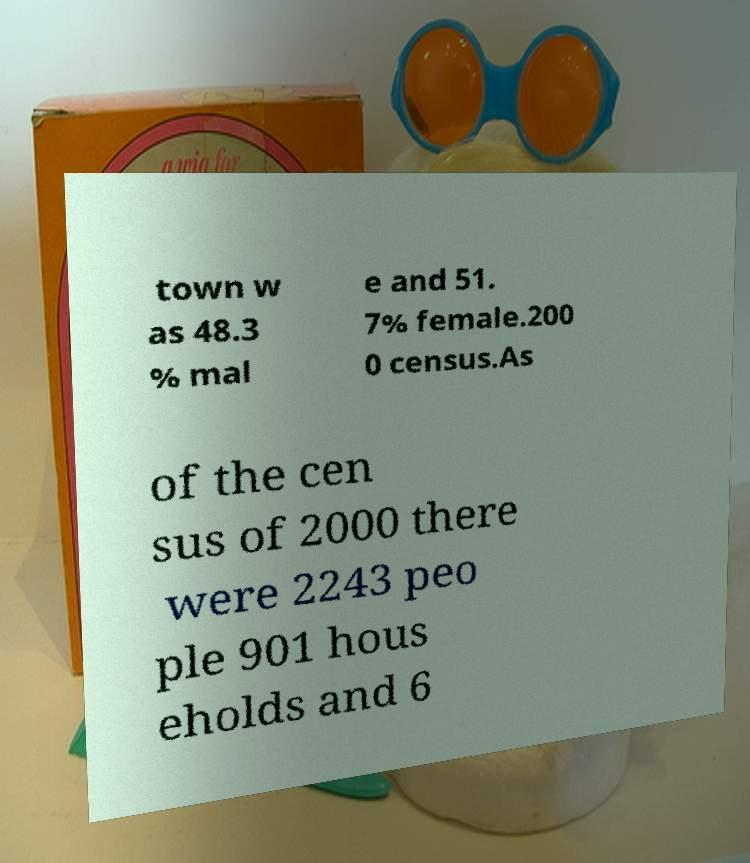Please identify and transcribe the text found in this image. town w as 48.3 % mal e and 51. 7% female.200 0 census.As of the cen sus of 2000 there were 2243 peo ple 901 hous eholds and 6 